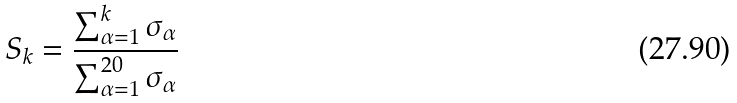<formula> <loc_0><loc_0><loc_500><loc_500>S _ { k } = \frac { \sum _ { \alpha = 1 } ^ { k } \sigma _ { \alpha } } { \sum _ { \alpha = 1 } ^ { 2 0 } \sigma _ { \alpha } }</formula> 